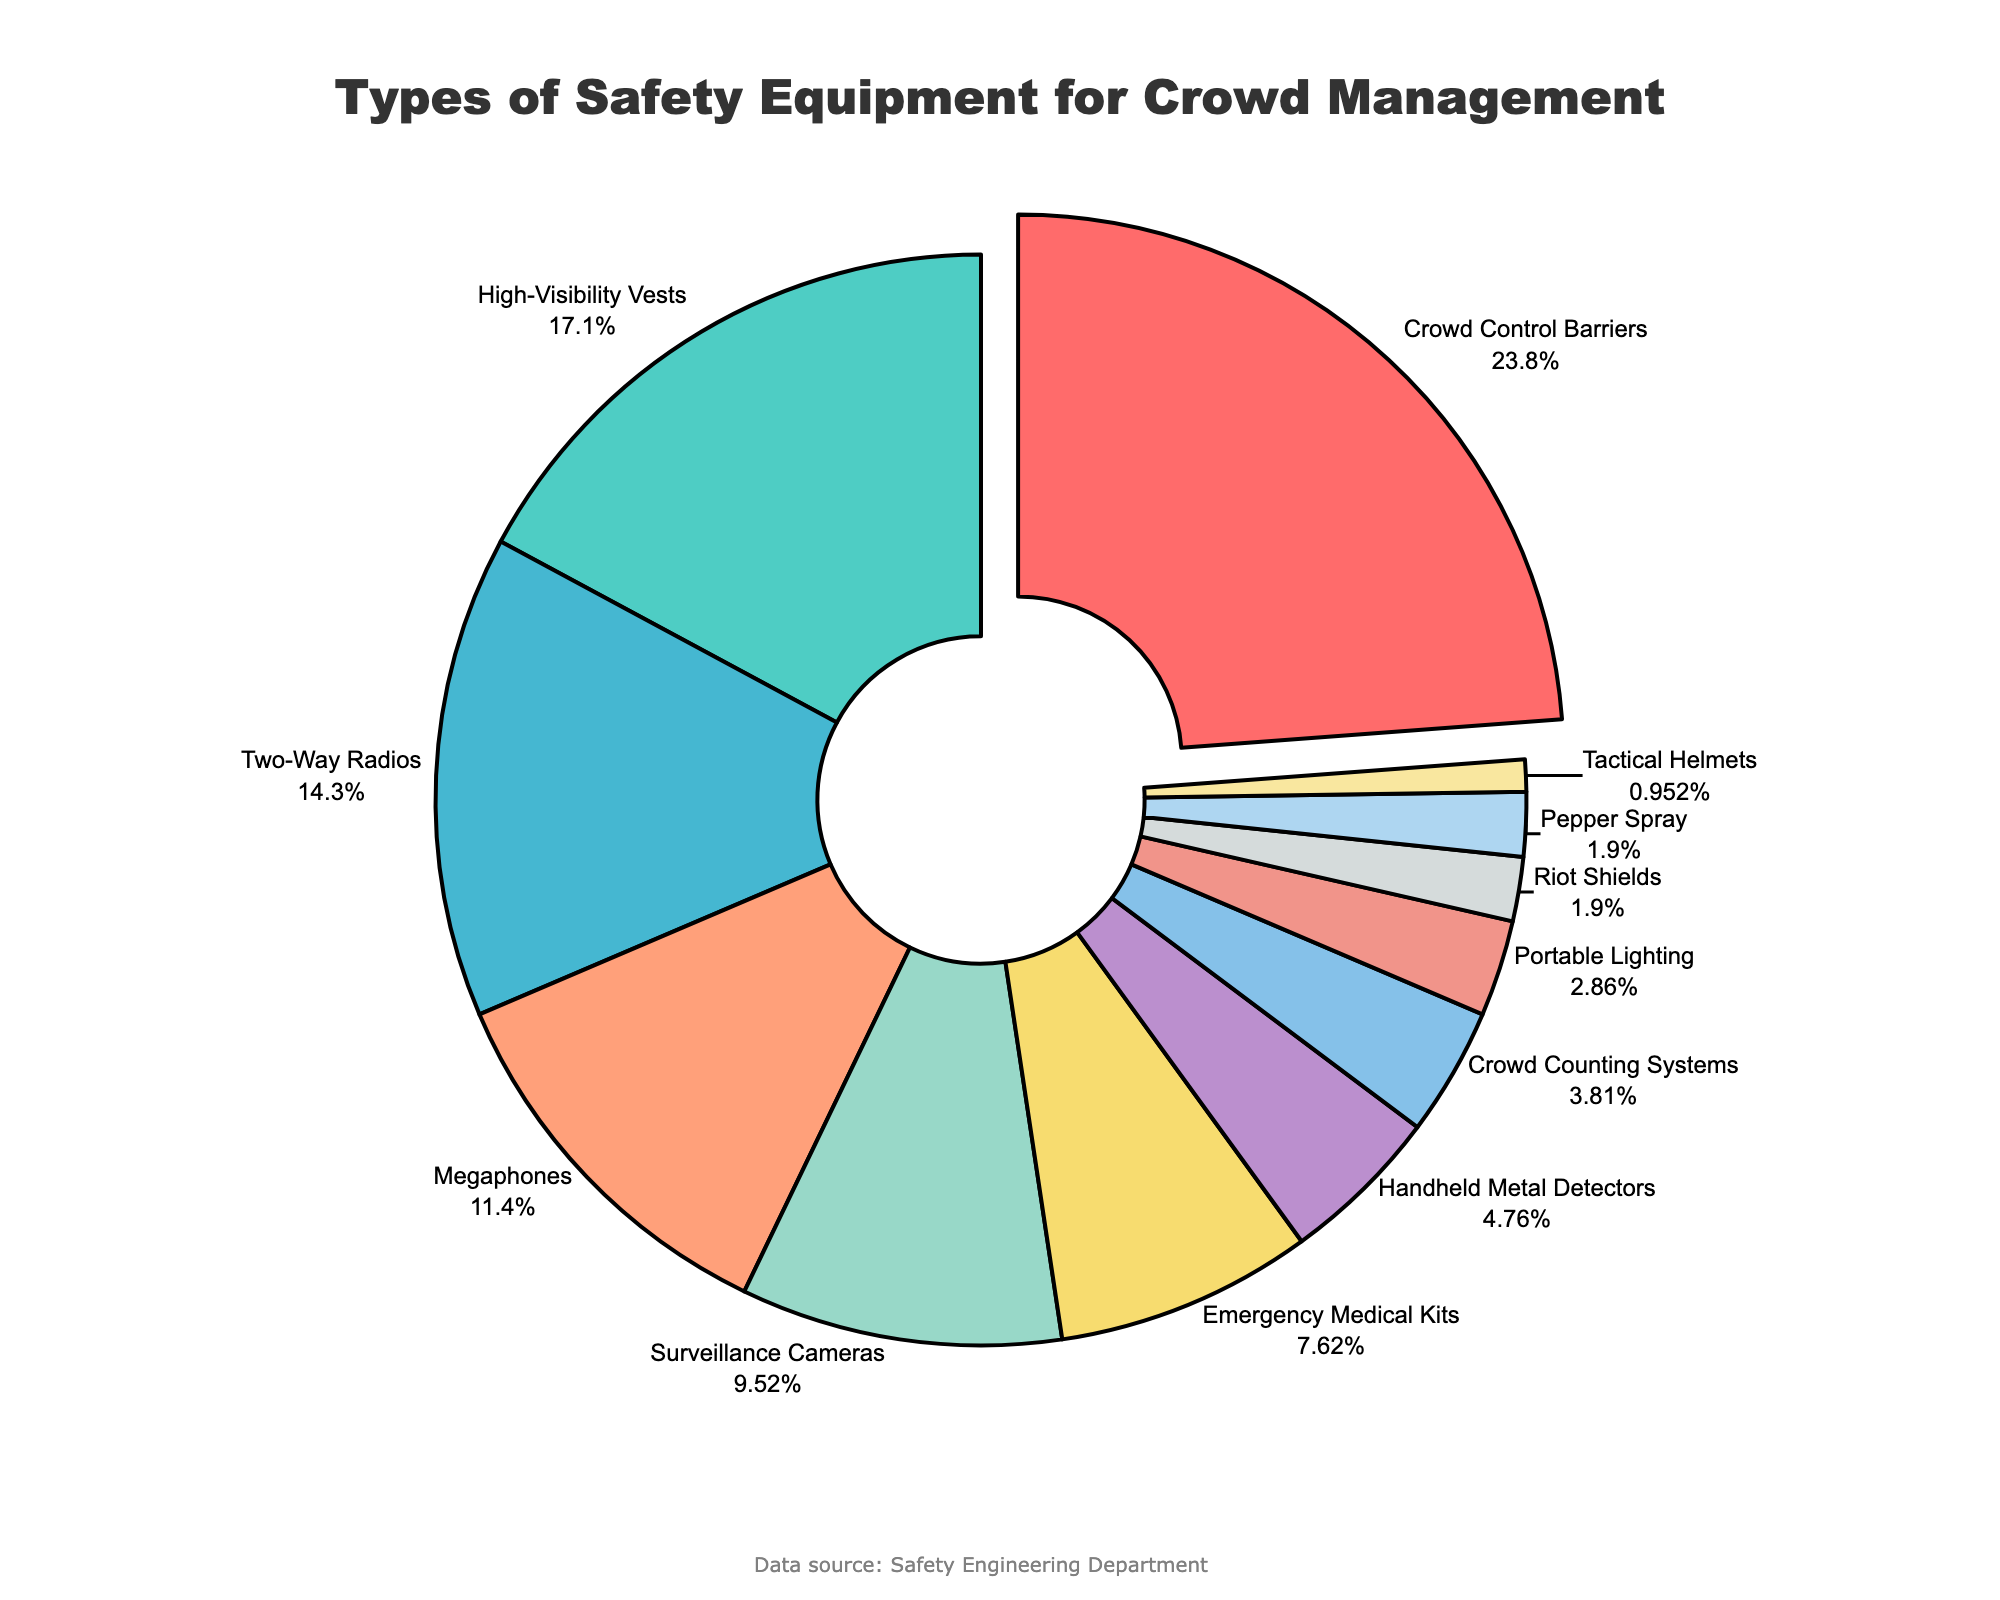Which type of safety equipment is deployed the most for crowd management? Look for the equipment type with the highest percentage. "Crowd Control Barriers" has the highest percentage at 25%.
Answer: Crowd Control Barriers How much more is the percentage of High-Visibility Vests compared to Tactical Helmets? Subtract the percentage of Tactical Helmets (1%) from High-Visibility Vests (18%). Calculation: 18% - 1% = 17%
Answer: 17% Which equipment types have an equal percentage deployment? Refer to the figure and identify any types with the same percentage values. Both "Riot Shields" and "Pepper Spray" have a percentage of 2%.
Answer: Riot Shields and Pepper Spray What is the total percentage of equipment types that account for less than 10% each? Sum the percentages of each type below 10%. Tactical Helmets (1%) + Pepper Spray (2%) + Riot Shields (2%) + Portable Lighting (3%) + Crowd Counting Systems (4%) + Handheld Metal Detectors (5%) + Emergency Medical Kits (8%) + Surveillance Cameras (10%). Calculation: 1% + 2% + 2% + 3% + 4% + 5% + 8% + 10% = 35%
Answer: 35% Is the deployment percentage of Megaphones higher or lower than Two-Way Radios? Compare the percentages of Megaphones (12%) and Two-Way Radios (15%). 12% is less than 15%, so it is lower.
Answer: Lower What is the combined percentage of Two-Way Radios and Megaphones? Add the percentages of Two-Way Radios (15%) and Megaphones (12%). Calculation: 15% + 12% = 27%
Answer: 27% Which equipment type is represented with a pull-out effect in the pie chart? Identify the equipment type that is visually separated from the rest. "Crowd Control Barriers" is pulled out for emphasis.
Answer: Crowd Control Barriers What color represents Emergency Medical Kits in the pie chart? Look at the legend or the pie chart section corresponding to Emergency Medical Kits. It is represented by a yellow color.
Answer: Yellow What is the difference in percentage between Surveillance Cameras and Emergency Medical Kits? Subtract the percentage of Emergency Medical Kits (8%) from Surveillance Cameras (10%). Calculation: 10% - 8% = 2%
Answer: 2% If the percentages of Crowd Control Barriers and Two-Way Radios were combined, what would be their total percentage? Add the percentages of Crowd Control Barriers (25%) and Two-Way Radios (15%). Calculation: 25% + 15% = 40%
Answer: 40% 